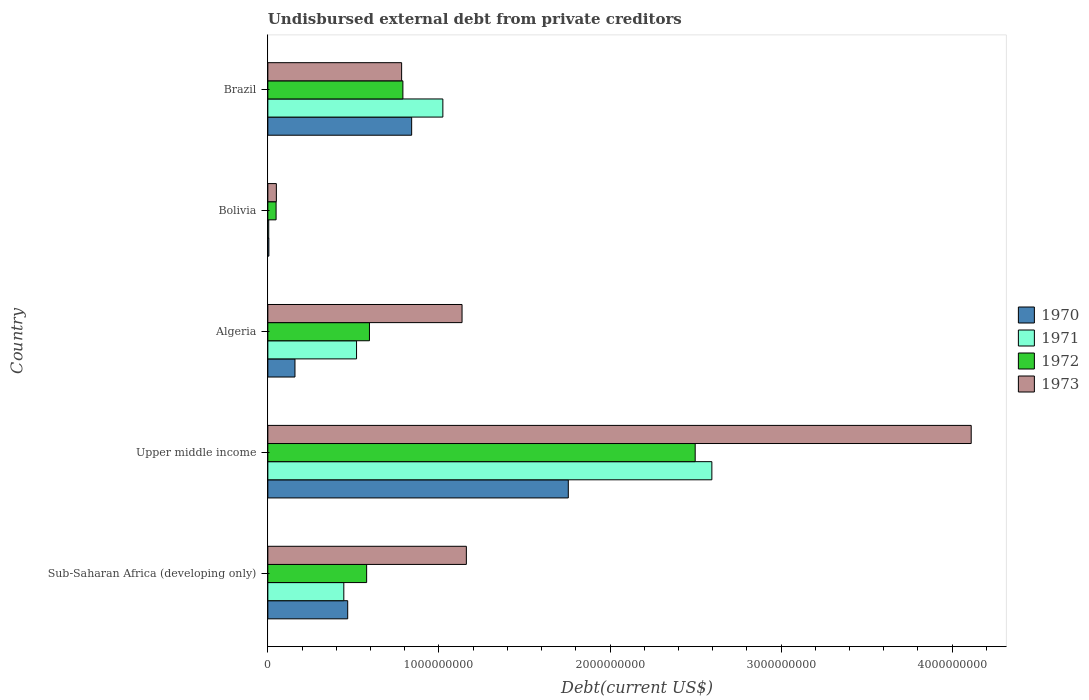How many groups of bars are there?
Offer a very short reply. 5. Are the number of bars per tick equal to the number of legend labels?
Your response must be concise. Yes. Are the number of bars on each tick of the Y-axis equal?
Your answer should be very brief. Yes. How many bars are there on the 4th tick from the top?
Provide a succinct answer. 4. What is the label of the 4th group of bars from the top?
Your response must be concise. Upper middle income. What is the total debt in 1971 in Upper middle income?
Ensure brevity in your answer.  2.60e+09. Across all countries, what is the maximum total debt in 1973?
Keep it short and to the point. 4.11e+09. Across all countries, what is the minimum total debt in 1971?
Ensure brevity in your answer.  5.25e+06. In which country was the total debt in 1972 maximum?
Your answer should be very brief. Upper middle income. What is the total total debt in 1970 in the graph?
Ensure brevity in your answer.  3.23e+09. What is the difference between the total debt in 1971 in Algeria and that in Sub-Saharan Africa (developing only)?
Ensure brevity in your answer.  7.44e+07. What is the difference between the total debt in 1970 in Bolivia and the total debt in 1972 in Algeria?
Offer a very short reply. -5.88e+08. What is the average total debt in 1973 per country?
Your answer should be very brief. 1.45e+09. What is the difference between the total debt in 1973 and total debt in 1972 in Sub-Saharan Africa (developing only)?
Make the answer very short. 5.83e+08. In how many countries, is the total debt in 1972 greater than 3400000000 US$?
Provide a short and direct response. 0. What is the ratio of the total debt in 1971 in Bolivia to that in Sub-Saharan Africa (developing only)?
Make the answer very short. 0.01. What is the difference between the highest and the second highest total debt in 1971?
Ensure brevity in your answer.  1.57e+09. What is the difference between the highest and the lowest total debt in 1971?
Provide a short and direct response. 2.59e+09. Is it the case that in every country, the sum of the total debt in 1973 and total debt in 1971 is greater than the sum of total debt in 1970 and total debt in 1972?
Your answer should be very brief. No. What does the 3rd bar from the top in Bolivia represents?
Your response must be concise. 1971. What does the 2nd bar from the bottom in Algeria represents?
Ensure brevity in your answer.  1971. Is it the case that in every country, the sum of the total debt in 1972 and total debt in 1973 is greater than the total debt in 1970?
Your answer should be very brief. Yes. How many bars are there?
Provide a short and direct response. 20. What is the difference between two consecutive major ticks on the X-axis?
Give a very brief answer. 1.00e+09. Are the values on the major ticks of X-axis written in scientific E-notation?
Give a very brief answer. No. Where does the legend appear in the graph?
Offer a very short reply. Center right. What is the title of the graph?
Provide a succinct answer. Undisbursed external debt from private creditors. What is the label or title of the X-axis?
Make the answer very short. Debt(current US$). What is the label or title of the Y-axis?
Keep it short and to the point. Country. What is the Debt(current US$) in 1970 in Sub-Saharan Africa (developing only)?
Give a very brief answer. 4.67e+08. What is the Debt(current US$) in 1971 in Sub-Saharan Africa (developing only)?
Offer a very short reply. 4.44e+08. What is the Debt(current US$) of 1972 in Sub-Saharan Africa (developing only)?
Your answer should be very brief. 5.77e+08. What is the Debt(current US$) of 1973 in Sub-Saharan Africa (developing only)?
Provide a succinct answer. 1.16e+09. What is the Debt(current US$) of 1970 in Upper middle income?
Give a very brief answer. 1.76e+09. What is the Debt(current US$) in 1971 in Upper middle income?
Offer a very short reply. 2.60e+09. What is the Debt(current US$) of 1972 in Upper middle income?
Your answer should be very brief. 2.50e+09. What is the Debt(current US$) of 1973 in Upper middle income?
Give a very brief answer. 4.11e+09. What is the Debt(current US$) of 1970 in Algeria?
Keep it short and to the point. 1.59e+08. What is the Debt(current US$) in 1971 in Algeria?
Your response must be concise. 5.18e+08. What is the Debt(current US$) of 1972 in Algeria?
Make the answer very short. 5.94e+08. What is the Debt(current US$) of 1973 in Algeria?
Provide a succinct answer. 1.14e+09. What is the Debt(current US$) in 1970 in Bolivia?
Ensure brevity in your answer.  6.05e+06. What is the Debt(current US$) in 1971 in Bolivia?
Your answer should be compact. 5.25e+06. What is the Debt(current US$) of 1972 in Bolivia?
Offer a terse response. 4.82e+07. What is the Debt(current US$) in 1973 in Bolivia?
Ensure brevity in your answer.  4.98e+07. What is the Debt(current US$) in 1970 in Brazil?
Your answer should be very brief. 8.41e+08. What is the Debt(current US$) of 1971 in Brazil?
Offer a very short reply. 1.02e+09. What is the Debt(current US$) in 1972 in Brazil?
Your answer should be very brief. 7.89e+08. What is the Debt(current US$) of 1973 in Brazil?
Provide a succinct answer. 7.82e+08. Across all countries, what is the maximum Debt(current US$) in 1970?
Offer a very short reply. 1.76e+09. Across all countries, what is the maximum Debt(current US$) of 1971?
Keep it short and to the point. 2.60e+09. Across all countries, what is the maximum Debt(current US$) of 1972?
Ensure brevity in your answer.  2.50e+09. Across all countries, what is the maximum Debt(current US$) in 1973?
Your answer should be compact. 4.11e+09. Across all countries, what is the minimum Debt(current US$) in 1970?
Your answer should be very brief. 6.05e+06. Across all countries, what is the minimum Debt(current US$) of 1971?
Your response must be concise. 5.25e+06. Across all countries, what is the minimum Debt(current US$) in 1972?
Offer a terse response. 4.82e+07. Across all countries, what is the minimum Debt(current US$) in 1973?
Offer a terse response. 4.98e+07. What is the total Debt(current US$) in 1970 in the graph?
Give a very brief answer. 3.23e+09. What is the total Debt(current US$) of 1971 in the graph?
Your answer should be compact. 4.59e+09. What is the total Debt(current US$) of 1972 in the graph?
Provide a succinct answer. 4.51e+09. What is the total Debt(current US$) of 1973 in the graph?
Make the answer very short. 7.24e+09. What is the difference between the Debt(current US$) in 1970 in Sub-Saharan Africa (developing only) and that in Upper middle income?
Make the answer very short. -1.29e+09. What is the difference between the Debt(current US$) in 1971 in Sub-Saharan Africa (developing only) and that in Upper middle income?
Keep it short and to the point. -2.15e+09. What is the difference between the Debt(current US$) of 1972 in Sub-Saharan Africa (developing only) and that in Upper middle income?
Your response must be concise. -1.92e+09. What is the difference between the Debt(current US$) of 1973 in Sub-Saharan Africa (developing only) and that in Upper middle income?
Give a very brief answer. -2.95e+09. What is the difference between the Debt(current US$) of 1970 in Sub-Saharan Africa (developing only) and that in Algeria?
Your answer should be very brief. 3.08e+08. What is the difference between the Debt(current US$) in 1971 in Sub-Saharan Africa (developing only) and that in Algeria?
Provide a succinct answer. -7.44e+07. What is the difference between the Debt(current US$) in 1972 in Sub-Saharan Africa (developing only) and that in Algeria?
Keep it short and to the point. -1.64e+07. What is the difference between the Debt(current US$) of 1973 in Sub-Saharan Africa (developing only) and that in Algeria?
Provide a succinct answer. 2.52e+07. What is the difference between the Debt(current US$) in 1970 in Sub-Saharan Africa (developing only) and that in Bolivia?
Give a very brief answer. 4.61e+08. What is the difference between the Debt(current US$) in 1971 in Sub-Saharan Africa (developing only) and that in Bolivia?
Keep it short and to the point. 4.39e+08. What is the difference between the Debt(current US$) in 1972 in Sub-Saharan Africa (developing only) and that in Bolivia?
Offer a terse response. 5.29e+08. What is the difference between the Debt(current US$) of 1973 in Sub-Saharan Africa (developing only) and that in Bolivia?
Provide a short and direct response. 1.11e+09. What is the difference between the Debt(current US$) of 1970 in Sub-Saharan Africa (developing only) and that in Brazil?
Offer a terse response. -3.74e+08. What is the difference between the Debt(current US$) of 1971 in Sub-Saharan Africa (developing only) and that in Brazil?
Offer a terse response. -5.79e+08. What is the difference between the Debt(current US$) of 1972 in Sub-Saharan Africa (developing only) and that in Brazil?
Ensure brevity in your answer.  -2.12e+08. What is the difference between the Debt(current US$) in 1973 in Sub-Saharan Africa (developing only) and that in Brazil?
Make the answer very short. 3.78e+08. What is the difference between the Debt(current US$) in 1970 in Upper middle income and that in Algeria?
Make the answer very short. 1.60e+09. What is the difference between the Debt(current US$) of 1971 in Upper middle income and that in Algeria?
Your answer should be compact. 2.08e+09. What is the difference between the Debt(current US$) in 1972 in Upper middle income and that in Algeria?
Make the answer very short. 1.90e+09. What is the difference between the Debt(current US$) in 1973 in Upper middle income and that in Algeria?
Provide a short and direct response. 2.98e+09. What is the difference between the Debt(current US$) in 1970 in Upper middle income and that in Bolivia?
Offer a very short reply. 1.75e+09. What is the difference between the Debt(current US$) of 1971 in Upper middle income and that in Bolivia?
Your answer should be very brief. 2.59e+09. What is the difference between the Debt(current US$) of 1972 in Upper middle income and that in Bolivia?
Make the answer very short. 2.45e+09. What is the difference between the Debt(current US$) in 1973 in Upper middle income and that in Bolivia?
Your answer should be compact. 4.06e+09. What is the difference between the Debt(current US$) in 1970 in Upper middle income and that in Brazil?
Make the answer very short. 9.16e+08. What is the difference between the Debt(current US$) of 1971 in Upper middle income and that in Brazil?
Provide a short and direct response. 1.57e+09. What is the difference between the Debt(current US$) in 1972 in Upper middle income and that in Brazil?
Your answer should be compact. 1.71e+09. What is the difference between the Debt(current US$) of 1973 in Upper middle income and that in Brazil?
Ensure brevity in your answer.  3.33e+09. What is the difference between the Debt(current US$) in 1970 in Algeria and that in Bolivia?
Your answer should be compact. 1.53e+08. What is the difference between the Debt(current US$) in 1971 in Algeria and that in Bolivia?
Keep it short and to the point. 5.13e+08. What is the difference between the Debt(current US$) in 1972 in Algeria and that in Bolivia?
Provide a short and direct response. 5.46e+08. What is the difference between the Debt(current US$) in 1973 in Algeria and that in Bolivia?
Offer a very short reply. 1.09e+09. What is the difference between the Debt(current US$) of 1970 in Algeria and that in Brazil?
Give a very brief answer. -6.82e+08. What is the difference between the Debt(current US$) of 1971 in Algeria and that in Brazil?
Ensure brevity in your answer.  -5.05e+08. What is the difference between the Debt(current US$) of 1972 in Algeria and that in Brazil?
Ensure brevity in your answer.  -1.95e+08. What is the difference between the Debt(current US$) in 1973 in Algeria and that in Brazil?
Keep it short and to the point. 3.53e+08. What is the difference between the Debt(current US$) of 1970 in Bolivia and that in Brazil?
Give a very brief answer. -8.35e+08. What is the difference between the Debt(current US$) of 1971 in Bolivia and that in Brazil?
Ensure brevity in your answer.  -1.02e+09. What is the difference between the Debt(current US$) in 1972 in Bolivia and that in Brazil?
Offer a very short reply. -7.41e+08. What is the difference between the Debt(current US$) of 1973 in Bolivia and that in Brazil?
Provide a short and direct response. -7.32e+08. What is the difference between the Debt(current US$) in 1970 in Sub-Saharan Africa (developing only) and the Debt(current US$) in 1971 in Upper middle income?
Your answer should be very brief. -2.13e+09. What is the difference between the Debt(current US$) in 1970 in Sub-Saharan Africa (developing only) and the Debt(current US$) in 1972 in Upper middle income?
Give a very brief answer. -2.03e+09. What is the difference between the Debt(current US$) in 1970 in Sub-Saharan Africa (developing only) and the Debt(current US$) in 1973 in Upper middle income?
Your answer should be compact. -3.64e+09. What is the difference between the Debt(current US$) in 1971 in Sub-Saharan Africa (developing only) and the Debt(current US$) in 1972 in Upper middle income?
Your answer should be very brief. -2.05e+09. What is the difference between the Debt(current US$) in 1971 in Sub-Saharan Africa (developing only) and the Debt(current US$) in 1973 in Upper middle income?
Ensure brevity in your answer.  -3.67e+09. What is the difference between the Debt(current US$) of 1972 in Sub-Saharan Africa (developing only) and the Debt(current US$) of 1973 in Upper middle income?
Make the answer very short. -3.53e+09. What is the difference between the Debt(current US$) in 1970 in Sub-Saharan Africa (developing only) and the Debt(current US$) in 1971 in Algeria?
Provide a short and direct response. -5.16e+07. What is the difference between the Debt(current US$) in 1970 in Sub-Saharan Africa (developing only) and the Debt(current US$) in 1972 in Algeria?
Offer a very short reply. -1.27e+08. What is the difference between the Debt(current US$) of 1970 in Sub-Saharan Africa (developing only) and the Debt(current US$) of 1973 in Algeria?
Offer a terse response. -6.68e+08. What is the difference between the Debt(current US$) in 1971 in Sub-Saharan Africa (developing only) and the Debt(current US$) in 1972 in Algeria?
Provide a succinct answer. -1.50e+08. What is the difference between the Debt(current US$) of 1971 in Sub-Saharan Africa (developing only) and the Debt(current US$) of 1973 in Algeria?
Your response must be concise. -6.91e+08. What is the difference between the Debt(current US$) of 1972 in Sub-Saharan Africa (developing only) and the Debt(current US$) of 1973 in Algeria?
Keep it short and to the point. -5.58e+08. What is the difference between the Debt(current US$) of 1970 in Sub-Saharan Africa (developing only) and the Debt(current US$) of 1971 in Bolivia?
Provide a succinct answer. 4.62e+08. What is the difference between the Debt(current US$) of 1970 in Sub-Saharan Africa (developing only) and the Debt(current US$) of 1972 in Bolivia?
Ensure brevity in your answer.  4.19e+08. What is the difference between the Debt(current US$) in 1970 in Sub-Saharan Africa (developing only) and the Debt(current US$) in 1973 in Bolivia?
Your answer should be compact. 4.17e+08. What is the difference between the Debt(current US$) of 1971 in Sub-Saharan Africa (developing only) and the Debt(current US$) of 1972 in Bolivia?
Your answer should be very brief. 3.96e+08. What is the difference between the Debt(current US$) of 1971 in Sub-Saharan Africa (developing only) and the Debt(current US$) of 1973 in Bolivia?
Keep it short and to the point. 3.94e+08. What is the difference between the Debt(current US$) of 1972 in Sub-Saharan Africa (developing only) and the Debt(current US$) of 1973 in Bolivia?
Offer a very short reply. 5.28e+08. What is the difference between the Debt(current US$) of 1970 in Sub-Saharan Africa (developing only) and the Debt(current US$) of 1971 in Brazil?
Keep it short and to the point. -5.56e+08. What is the difference between the Debt(current US$) in 1970 in Sub-Saharan Africa (developing only) and the Debt(current US$) in 1972 in Brazil?
Give a very brief answer. -3.23e+08. What is the difference between the Debt(current US$) of 1970 in Sub-Saharan Africa (developing only) and the Debt(current US$) of 1973 in Brazil?
Provide a short and direct response. -3.15e+08. What is the difference between the Debt(current US$) in 1971 in Sub-Saharan Africa (developing only) and the Debt(current US$) in 1972 in Brazil?
Make the answer very short. -3.45e+08. What is the difference between the Debt(current US$) in 1971 in Sub-Saharan Africa (developing only) and the Debt(current US$) in 1973 in Brazil?
Give a very brief answer. -3.38e+08. What is the difference between the Debt(current US$) of 1972 in Sub-Saharan Africa (developing only) and the Debt(current US$) of 1973 in Brazil?
Provide a short and direct response. -2.05e+08. What is the difference between the Debt(current US$) of 1970 in Upper middle income and the Debt(current US$) of 1971 in Algeria?
Offer a very short reply. 1.24e+09. What is the difference between the Debt(current US$) in 1970 in Upper middle income and the Debt(current US$) in 1972 in Algeria?
Your answer should be very brief. 1.16e+09. What is the difference between the Debt(current US$) of 1970 in Upper middle income and the Debt(current US$) of 1973 in Algeria?
Ensure brevity in your answer.  6.21e+08. What is the difference between the Debt(current US$) in 1971 in Upper middle income and the Debt(current US$) in 1972 in Algeria?
Provide a succinct answer. 2.00e+09. What is the difference between the Debt(current US$) of 1971 in Upper middle income and the Debt(current US$) of 1973 in Algeria?
Make the answer very short. 1.46e+09. What is the difference between the Debt(current US$) of 1972 in Upper middle income and the Debt(current US$) of 1973 in Algeria?
Ensure brevity in your answer.  1.36e+09. What is the difference between the Debt(current US$) in 1970 in Upper middle income and the Debt(current US$) in 1971 in Bolivia?
Provide a succinct answer. 1.75e+09. What is the difference between the Debt(current US$) of 1970 in Upper middle income and the Debt(current US$) of 1972 in Bolivia?
Your response must be concise. 1.71e+09. What is the difference between the Debt(current US$) in 1970 in Upper middle income and the Debt(current US$) in 1973 in Bolivia?
Ensure brevity in your answer.  1.71e+09. What is the difference between the Debt(current US$) in 1971 in Upper middle income and the Debt(current US$) in 1972 in Bolivia?
Your response must be concise. 2.55e+09. What is the difference between the Debt(current US$) of 1971 in Upper middle income and the Debt(current US$) of 1973 in Bolivia?
Give a very brief answer. 2.55e+09. What is the difference between the Debt(current US$) of 1972 in Upper middle income and the Debt(current US$) of 1973 in Bolivia?
Your response must be concise. 2.45e+09. What is the difference between the Debt(current US$) in 1970 in Upper middle income and the Debt(current US$) in 1971 in Brazil?
Keep it short and to the point. 7.33e+08. What is the difference between the Debt(current US$) of 1970 in Upper middle income and the Debt(current US$) of 1972 in Brazil?
Keep it short and to the point. 9.67e+08. What is the difference between the Debt(current US$) in 1970 in Upper middle income and the Debt(current US$) in 1973 in Brazil?
Provide a short and direct response. 9.74e+08. What is the difference between the Debt(current US$) in 1971 in Upper middle income and the Debt(current US$) in 1972 in Brazil?
Your answer should be very brief. 1.81e+09. What is the difference between the Debt(current US$) of 1971 in Upper middle income and the Debt(current US$) of 1973 in Brazil?
Your answer should be compact. 1.81e+09. What is the difference between the Debt(current US$) of 1972 in Upper middle income and the Debt(current US$) of 1973 in Brazil?
Give a very brief answer. 1.72e+09. What is the difference between the Debt(current US$) in 1970 in Algeria and the Debt(current US$) in 1971 in Bolivia?
Make the answer very short. 1.53e+08. What is the difference between the Debt(current US$) in 1970 in Algeria and the Debt(current US$) in 1972 in Bolivia?
Ensure brevity in your answer.  1.10e+08. What is the difference between the Debt(current US$) of 1970 in Algeria and the Debt(current US$) of 1973 in Bolivia?
Provide a short and direct response. 1.09e+08. What is the difference between the Debt(current US$) in 1971 in Algeria and the Debt(current US$) in 1972 in Bolivia?
Your answer should be compact. 4.70e+08. What is the difference between the Debt(current US$) of 1971 in Algeria and the Debt(current US$) of 1973 in Bolivia?
Provide a succinct answer. 4.69e+08. What is the difference between the Debt(current US$) of 1972 in Algeria and the Debt(current US$) of 1973 in Bolivia?
Make the answer very short. 5.44e+08. What is the difference between the Debt(current US$) of 1970 in Algeria and the Debt(current US$) of 1971 in Brazil?
Make the answer very short. -8.64e+08. What is the difference between the Debt(current US$) of 1970 in Algeria and the Debt(current US$) of 1972 in Brazil?
Provide a short and direct response. -6.31e+08. What is the difference between the Debt(current US$) in 1970 in Algeria and the Debt(current US$) in 1973 in Brazil?
Provide a short and direct response. -6.23e+08. What is the difference between the Debt(current US$) in 1971 in Algeria and the Debt(current US$) in 1972 in Brazil?
Your answer should be very brief. -2.71e+08. What is the difference between the Debt(current US$) of 1971 in Algeria and the Debt(current US$) of 1973 in Brazil?
Provide a succinct answer. -2.64e+08. What is the difference between the Debt(current US$) of 1972 in Algeria and the Debt(current US$) of 1973 in Brazil?
Make the answer very short. -1.88e+08. What is the difference between the Debt(current US$) in 1970 in Bolivia and the Debt(current US$) in 1971 in Brazil?
Keep it short and to the point. -1.02e+09. What is the difference between the Debt(current US$) in 1970 in Bolivia and the Debt(current US$) in 1972 in Brazil?
Ensure brevity in your answer.  -7.83e+08. What is the difference between the Debt(current US$) in 1970 in Bolivia and the Debt(current US$) in 1973 in Brazil?
Keep it short and to the point. -7.76e+08. What is the difference between the Debt(current US$) of 1971 in Bolivia and the Debt(current US$) of 1972 in Brazil?
Keep it short and to the point. -7.84e+08. What is the difference between the Debt(current US$) in 1971 in Bolivia and the Debt(current US$) in 1973 in Brazil?
Ensure brevity in your answer.  -7.77e+08. What is the difference between the Debt(current US$) in 1972 in Bolivia and the Debt(current US$) in 1973 in Brazil?
Provide a succinct answer. -7.34e+08. What is the average Debt(current US$) of 1970 per country?
Make the answer very short. 6.46e+08. What is the average Debt(current US$) of 1971 per country?
Provide a succinct answer. 9.17e+08. What is the average Debt(current US$) in 1972 per country?
Give a very brief answer. 9.01e+08. What is the average Debt(current US$) of 1973 per country?
Provide a short and direct response. 1.45e+09. What is the difference between the Debt(current US$) in 1970 and Debt(current US$) in 1971 in Sub-Saharan Africa (developing only)?
Your response must be concise. 2.28e+07. What is the difference between the Debt(current US$) of 1970 and Debt(current US$) of 1972 in Sub-Saharan Africa (developing only)?
Offer a very short reply. -1.11e+08. What is the difference between the Debt(current US$) in 1970 and Debt(current US$) in 1973 in Sub-Saharan Africa (developing only)?
Provide a short and direct response. -6.94e+08. What is the difference between the Debt(current US$) in 1971 and Debt(current US$) in 1972 in Sub-Saharan Africa (developing only)?
Provide a succinct answer. -1.33e+08. What is the difference between the Debt(current US$) in 1971 and Debt(current US$) in 1973 in Sub-Saharan Africa (developing only)?
Give a very brief answer. -7.16e+08. What is the difference between the Debt(current US$) in 1972 and Debt(current US$) in 1973 in Sub-Saharan Africa (developing only)?
Ensure brevity in your answer.  -5.83e+08. What is the difference between the Debt(current US$) in 1970 and Debt(current US$) in 1971 in Upper middle income?
Provide a succinct answer. -8.39e+08. What is the difference between the Debt(current US$) in 1970 and Debt(current US$) in 1972 in Upper middle income?
Offer a very short reply. -7.42e+08. What is the difference between the Debt(current US$) of 1970 and Debt(current US$) of 1973 in Upper middle income?
Provide a succinct answer. -2.36e+09. What is the difference between the Debt(current US$) of 1971 and Debt(current US$) of 1972 in Upper middle income?
Your answer should be very brief. 9.75e+07. What is the difference between the Debt(current US$) in 1971 and Debt(current US$) in 1973 in Upper middle income?
Offer a terse response. -1.52e+09. What is the difference between the Debt(current US$) in 1972 and Debt(current US$) in 1973 in Upper middle income?
Offer a terse response. -1.61e+09. What is the difference between the Debt(current US$) in 1970 and Debt(current US$) in 1971 in Algeria?
Your answer should be compact. -3.60e+08. What is the difference between the Debt(current US$) in 1970 and Debt(current US$) in 1972 in Algeria?
Provide a short and direct response. -4.35e+08. What is the difference between the Debt(current US$) of 1970 and Debt(current US$) of 1973 in Algeria?
Keep it short and to the point. -9.77e+08. What is the difference between the Debt(current US$) in 1971 and Debt(current US$) in 1972 in Algeria?
Give a very brief answer. -7.55e+07. What is the difference between the Debt(current US$) of 1971 and Debt(current US$) of 1973 in Algeria?
Provide a succinct answer. -6.17e+08. What is the difference between the Debt(current US$) of 1972 and Debt(current US$) of 1973 in Algeria?
Give a very brief answer. -5.41e+08. What is the difference between the Debt(current US$) in 1970 and Debt(current US$) in 1971 in Bolivia?
Your answer should be compact. 8.02e+05. What is the difference between the Debt(current US$) in 1970 and Debt(current US$) in 1972 in Bolivia?
Give a very brief answer. -4.22e+07. What is the difference between the Debt(current US$) of 1970 and Debt(current US$) of 1973 in Bolivia?
Your answer should be very brief. -4.37e+07. What is the difference between the Debt(current US$) of 1971 and Debt(current US$) of 1972 in Bolivia?
Offer a terse response. -4.30e+07. What is the difference between the Debt(current US$) in 1971 and Debt(current US$) in 1973 in Bolivia?
Offer a very short reply. -4.45e+07. What is the difference between the Debt(current US$) in 1972 and Debt(current US$) in 1973 in Bolivia?
Give a very brief answer. -1.58e+06. What is the difference between the Debt(current US$) of 1970 and Debt(current US$) of 1971 in Brazil?
Provide a short and direct response. -1.82e+08. What is the difference between the Debt(current US$) of 1970 and Debt(current US$) of 1972 in Brazil?
Ensure brevity in your answer.  5.12e+07. What is the difference between the Debt(current US$) in 1970 and Debt(current US$) in 1973 in Brazil?
Offer a terse response. 5.86e+07. What is the difference between the Debt(current US$) of 1971 and Debt(current US$) of 1972 in Brazil?
Keep it short and to the point. 2.34e+08. What is the difference between the Debt(current US$) of 1971 and Debt(current US$) of 1973 in Brazil?
Offer a terse response. 2.41e+08. What is the difference between the Debt(current US$) of 1972 and Debt(current US$) of 1973 in Brazil?
Your answer should be very brief. 7.41e+06. What is the ratio of the Debt(current US$) of 1970 in Sub-Saharan Africa (developing only) to that in Upper middle income?
Offer a terse response. 0.27. What is the ratio of the Debt(current US$) in 1971 in Sub-Saharan Africa (developing only) to that in Upper middle income?
Your response must be concise. 0.17. What is the ratio of the Debt(current US$) of 1972 in Sub-Saharan Africa (developing only) to that in Upper middle income?
Your answer should be compact. 0.23. What is the ratio of the Debt(current US$) in 1973 in Sub-Saharan Africa (developing only) to that in Upper middle income?
Your response must be concise. 0.28. What is the ratio of the Debt(current US$) in 1970 in Sub-Saharan Africa (developing only) to that in Algeria?
Your response must be concise. 2.94. What is the ratio of the Debt(current US$) of 1971 in Sub-Saharan Africa (developing only) to that in Algeria?
Keep it short and to the point. 0.86. What is the ratio of the Debt(current US$) in 1972 in Sub-Saharan Africa (developing only) to that in Algeria?
Make the answer very short. 0.97. What is the ratio of the Debt(current US$) in 1973 in Sub-Saharan Africa (developing only) to that in Algeria?
Offer a very short reply. 1.02. What is the ratio of the Debt(current US$) in 1970 in Sub-Saharan Africa (developing only) to that in Bolivia?
Offer a very short reply. 77.19. What is the ratio of the Debt(current US$) of 1971 in Sub-Saharan Africa (developing only) to that in Bolivia?
Offer a terse response. 84.64. What is the ratio of the Debt(current US$) of 1972 in Sub-Saharan Africa (developing only) to that in Bolivia?
Offer a terse response. 11.98. What is the ratio of the Debt(current US$) in 1973 in Sub-Saharan Africa (developing only) to that in Bolivia?
Keep it short and to the point. 23.31. What is the ratio of the Debt(current US$) of 1970 in Sub-Saharan Africa (developing only) to that in Brazil?
Provide a succinct answer. 0.56. What is the ratio of the Debt(current US$) in 1971 in Sub-Saharan Africa (developing only) to that in Brazil?
Your answer should be very brief. 0.43. What is the ratio of the Debt(current US$) in 1972 in Sub-Saharan Africa (developing only) to that in Brazil?
Your answer should be very brief. 0.73. What is the ratio of the Debt(current US$) in 1973 in Sub-Saharan Africa (developing only) to that in Brazil?
Your response must be concise. 1.48. What is the ratio of the Debt(current US$) in 1970 in Upper middle income to that in Algeria?
Keep it short and to the point. 11.08. What is the ratio of the Debt(current US$) in 1971 in Upper middle income to that in Algeria?
Provide a short and direct response. 5.01. What is the ratio of the Debt(current US$) in 1972 in Upper middle income to that in Algeria?
Make the answer very short. 4.21. What is the ratio of the Debt(current US$) in 1973 in Upper middle income to that in Algeria?
Your answer should be very brief. 3.62. What is the ratio of the Debt(current US$) in 1970 in Upper middle income to that in Bolivia?
Offer a terse response. 290.38. What is the ratio of the Debt(current US$) in 1971 in Upper middle income to that in Bolivia?
Offer a terse response. 494.74. What is the ratio of the Debt(current US$) of 1972 in Upper middle income to that in Bolivia?
Your response must be concise. 51.81. What is the ratio of the Debt(current US$) in 1973 in Upper middle income to that in Bolivia?
Provide a succinct answer. 82.58. What is the ratio of the Debt(current US$) of 1970 in Upper middle income to that in Brazil?
Provide a succinct answer. 2.09. What is the ratio of the Debt(current US$) in 1971 in Upper middle income to that in Brazil?
Keep it short and to the point. 2.54. What is the ratio of the Debt(current US$) in 1972 in Upper middle income to that in Brazil?
Keep it short and to the point. 3.16. What is the ratio of the Debt(current US$) of 1973 in Upper middle income to that in Brazil?
Offer a very short reply. 5.26. What is the ratio of the Debt(current US$) in 1970 in Algeria to that in Bolivia?
Provide a succinct answer. 26.22. What is the ratio of the Debt(current US$) in 1971 in Algeria to that in Bolivia?
Offer a terse response. 98.83. What is the ratio of the Debt(current US$) in 1972 in Algeria to that in Bolivia?
Give a very brief answer. 12.32. What is the ratio of the Debt(current US$) in 1973 in Algeria to that in Bolivia?
Make the answer very short. 22.8. What is the ratio of the Debt(current US$) in 1970 in Algeria to that in Brazil?
Make the answer very short. 0.19. What is the ratio of the Debt(current US$) in 1971 in Algeria to that in Brazil?
Make the answer very short. 0.51. What is the ratio of the Debt(current US$) in 1972 in Algeria to that in Brazil?
Offer a terse response. 0.75. What is the ratio of the Debt(current US$) of 1973 in Algeria to that in Brazil?
Keep it short and to the point. 1.45. What is the ratio of the Debt(current US$) in 1970 in Bolivia to that in Brazil?
Offer a very short reply. 0.01. What is the ratio of the Debt(current US$) in 1971 in Bolivia to that in Brazil?
Offer a terse response. 0.01. What is the ratio of the Debt(current US$) of 1972 in Bolivia to that in Brazil?
Ensure brevity in your answer.  0.06. What is the ratio of the Debt(current US$) in 1973 in Bolivia to that in Brazil?
Your answer should be compact. 0.06. What is the difference between the highest and the second highest Debt(current US$) in 1970?
Keep it short and to the point. 9.16e+08. What is the difference between the highest and the second highest Debt(current US$) of 1971?
Your answer should be compact. 1.57e+09. What is the difference between the highest and the second highest Debt(current US$) in 1972?
Your answer should be compact. 1.71e+09. What is the difference between the highest and the second highest Debt(current US$) in 1973?
Your response must be concise. 2.95e+09. What is the difference between the highest and the lowest Debt(current US$) in 1970?
Your response must be concise. 1.75e+09. What is the difference between the highest and the lowest Debt(current US$) of 1971?
Offer a terse response. 2.59e+09. What is the difference between the highest and the lowest Debt(current US$) in 1972?
Give a very brief answer. 2.45e+09. What is the difference between the highest and the lowest Debt(current US$) in 1973?
Keep it short and to the point. 4.06e+09. 